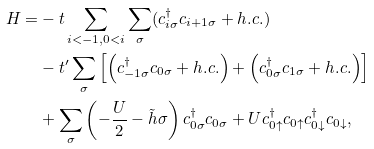<formula> <loc_0><loc_0><loc_500><loc_500>H = & - t \sum _ { i < - 1 , 0 < i } \sum _ { \sigma } ( c _ { i \sigma } ^ { \dagger } c _ { i + 1 \sigma } + h . c . ) \\ & - t ^ { \prime } \sum _ { \sigma } \left [ \left ( c _ { - 1 \sigma } ^ { \dagger } c _ { 0 \sigma } + h . c . \right ) + \left ( c _ { 0 \sigma } ^ { \dagger } c _ { 1 \sigma } + h . c . \right ) \right ] \\ & + \sum _ { \sigma } \left ( - \frac { U } { 2 } - \tilde { h } \sigma \right ) c _ { 0 \sigma } ^ { \dagger } c _ { 0 \sigma } + U c _ { 0 \uparrow } ^ { \dagger } c _ { 0 \uparrow } c _ { 0 \downarrow } ^ { \dagger } c _ { 0 \downarrow } ,</formula> 